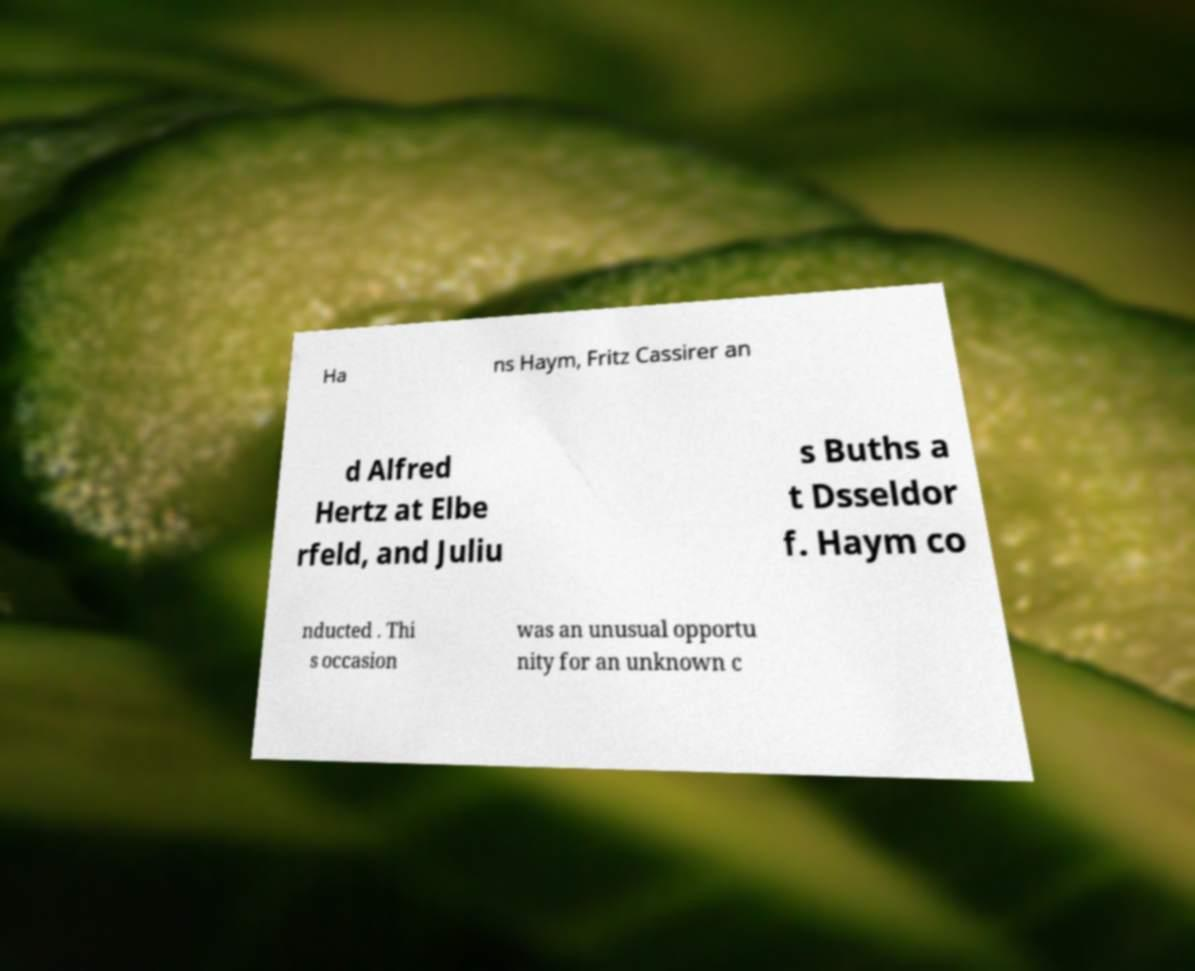Could you assist in decoding the text presented in this image and type it out clearly? Ha ns Haym, Fritz Cassirer an d Alfred Hertz at Elbe rfeld, and Juliu s Buths a t Dsseldor f. Haym co nducted . Thi s occasion was an unusual opportu nity for an unknown c 